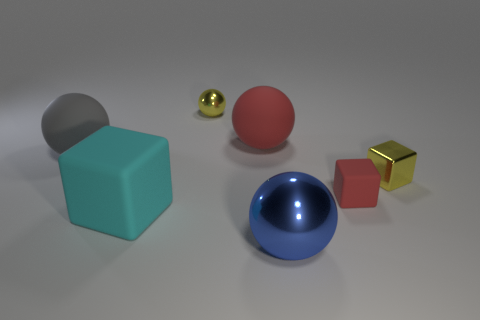Subtract all tiny metal cubes. How many cubes are left? 2 Add 2 red cubes. How many objects exist? 9 Subtract 1 cubes. How many cubes are left? 2 Subtract all gray balls. How many balls are left? 3 Subtract all blocks. How many objects are left? 4 Subtract all purple balls. Subtract all brown cylinders. How many balls are left? 4 Add 5 red rubber cylinders. How many red rubber cylinders exist? 5 Subtract 0 blue cubes. How many objects are left? 7 Subtract all large rubber things. Subtract all big gray rubber cylinders. How many objects are left? 4 Add 3 cyan matte blocks. How many cyan matte blocks are left? 4 